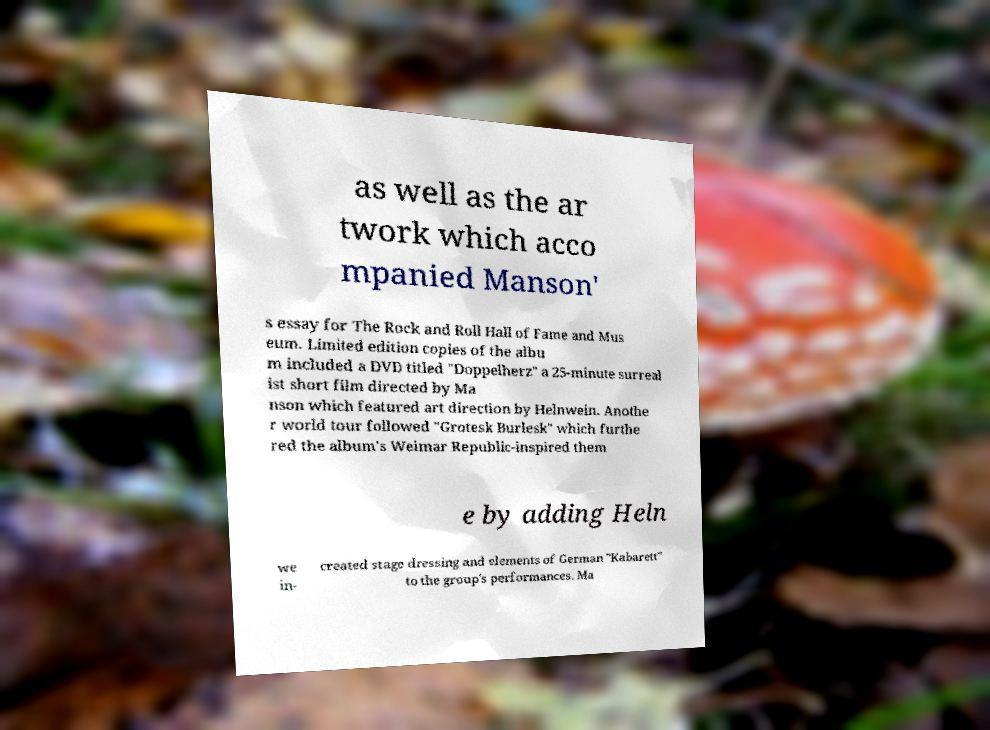Please read and relay the text visible in this image. What does it say? as well as the ar twork which acco mpanied Manson' s essay for The Rock and Roll Hall of Fame and Mus eum. Limited edition copies of the albu m included a DVD titled "Doppelherz" a 25-minute surreal ist short film directed by Ma nson which featured art direction by Helnwein. Anothe r world tour followed "Grotesk Burlesk" which furthe red the album's Weimar Republic-inspired them e by adding Heln we in- created stage dressing and elements of German "Kabarett" to the group's performances. Ma 